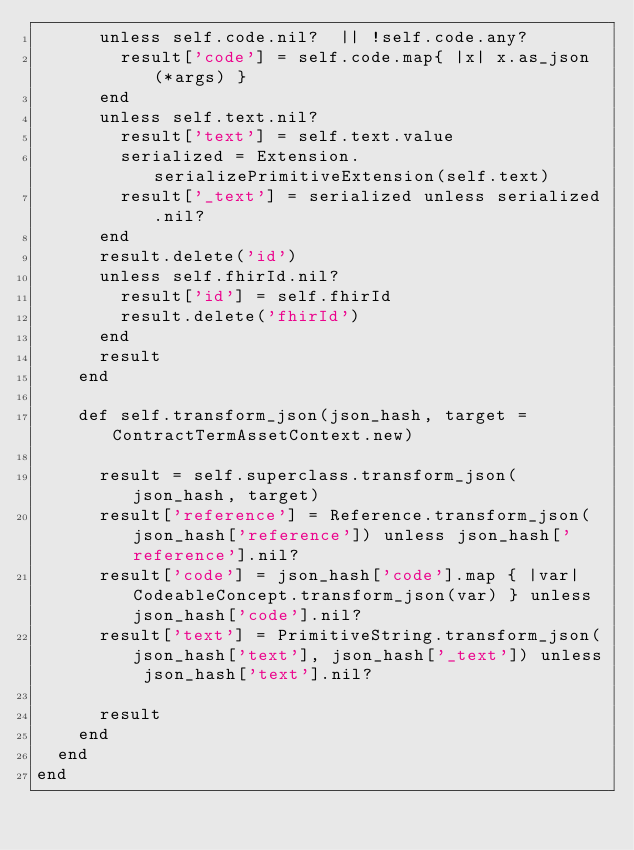Convert code to text. <code><loc_0><loc_0><loc_500><loc_500><_Ruby_>      unless self.code.nil?  || !self.code.any? 
        result['code'] = self.code.map{ |x| x.as_json(*args) }
      end
      unless self.text.nil? 
        result['text'] = self.text.value
        serialized = Extension.serializePrimitiveExtension(self.text)            
        result['_text'] = serialized unless serialized.nil?
      end
      result.delete('id')
      unless self.fhirId.nil?
        result['id'] = self.fhirId
        result.delete('fhirId')
      end  
      result
    end

    def self.transform_json(json_hash, target = ContractTermAssetContext.new)
    
      result = self.superclass.transform_json(json_hash, target)
      result['reference'] = Reference.transform_json(json_hash['reference']) unless json_hash['reference'].nil?
      result['code'] = json_hash['code'].map { |var| CodeableConcept.transform_json(var) } unless json_hash['code'].nil?
      result['text'] = PrimitiveString.transform_json(json_hash['text'], json_hash['_text']) unless json_hash['text'].nil?

      result
    end
  end
end
</code> 